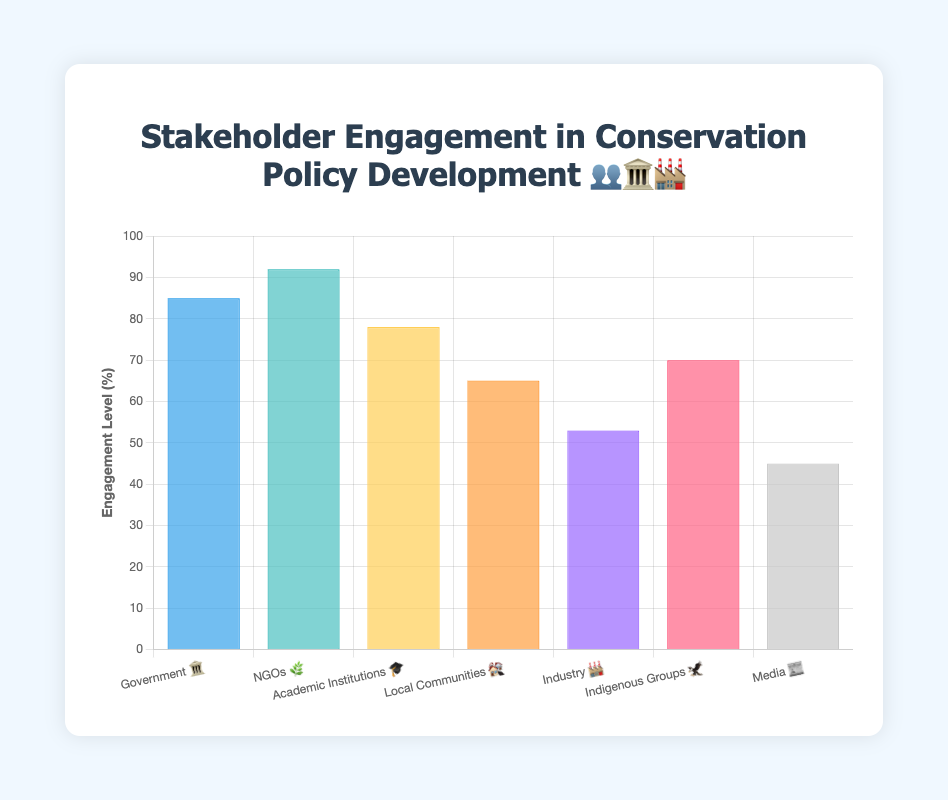What is the title of the chart? The title is displayed at the top of the chart in bold font and reads "Stakeholder Engagement in Conservation Policy Development 👥🏛️🏭."
Answer: Stakeholder Engagement in Conservation Policy Development 👥🏛️🏭 Which sector shows the highest level of engagement? The y-axis represents the engagement level, and the highest bar belongs to the NGOs 🌿.
Answer: NGOs 🌿 What is the engagement level for Industry 🏭? Look at the bar representing Industry 🏭 and check its height against the y-axis. The bar stops at 53.
Answer: 53 Compare the engagement level between Government 🏛️ and Media 📰. Government 🏛️ has an engagement level of 85, while Media 📰 has an engagement level of 45. The difference is 85 - 45 = 40.
Answer: Government 🏛️ is 40 higher than Media 📰 Which sectors have engagement levels over 70%? Check each bar and note those higher than the 70% mark on the y-axis. The sectors are Government 🏛️ (85), NGOs 🌿 (92), and Academic Institutions 🎓 (78).
Answer: Government 🏛️, NGOs 🌿, Academic Institutions 🎓 What is the total engagement level of Local Communities 🏘️ and Indigenous Groups 🦅? Add the engagement levels for these sectors: Local Communities 🏘️ (65) + Indigenous Groups 🦅 (70) = 135.
Answer: 135 What percentage of sectors have an engagement level below 60%? There are 7 sectors in total. Media 📰 (45) and Industry 🏭 (53) are below 60%. The percentage is (2/7) * 100 ≈ 28.57%.
Answer: About 28.57% Find the average engagement level across all sectors. Add all engagement levels: 85 (Government) + 92 (NGOs) + 78 (Academic Institutions) + 65 (Local Communities) + 53 (Industry) + 70 (Indigenous Groups) + 45 (Media) = 488. Divide by the number of sectors, 488 / 7 ≈ 69.71.
Answer: 69.71 Which sector shows the lowest level of engagement? The lowest engagement level is indicated by the shortest bar, which is Media 📰 at 45.
Answer: Media 📰 Does Indigenous Groups 🦅 have a higher engagement than Academic Institutions 🎓? Indigenous Groups 🦅 have an engagement level of 70, whereas Academic Institutions 🎓 have 78, so no.
Answer: No 